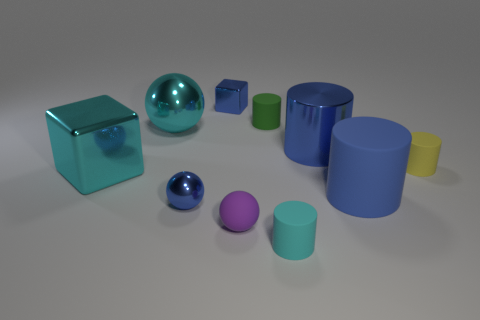There is a large thing that is the same color as the big metallic ball; what material is it?
Provide a short and direct response. Metal. Is the number of tiny yellow cylinders in front of the tiny blue metal ball less than the number of blue metal cylinders on the left side of the small cyan rubber object?
Provide a succinct answer. No. What number of things are either small matte things behind the tiny purple rubber object or cyan spheres?
Provide a succinct answer. 3. There is a small blue object to the right of the tiny blue thing that is in front of the tiny green cylinder; what is its shape?
Give a very brief answer. Cube. Is there another rubber cylinder of the same size as the yellow cylinder?
Make the answer very short. Yes. Is the number of large blue matte things greater than the number of blue metallic objects?
Offer a terse response. No. Does the blue thing behind the tiny green cylinder have the same size as the cyan thing that is in front of the blue rubber object?
Provide a succinct answer. Yes. What number of tiny objects are both in front of the big rubber thing and on the right side of the tiny green cylinder?
Give a very brief answer. 1. There is a large metal thing that is the same shape as the purple rubber object; what color is it?
Offer a very short reply. Cyan. Are there fewer small green cylinders than big gray matte objects?
Your response must be concise. No. 